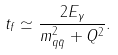<formula> <loc_0><loc_0><loc_500><loc_500>t _ { f } \simeq \frac { 2 E _ { \gamma } } { m _ { q \bar { q } } ^ { 2 } + Q ^ { 2 } } .</formula> 